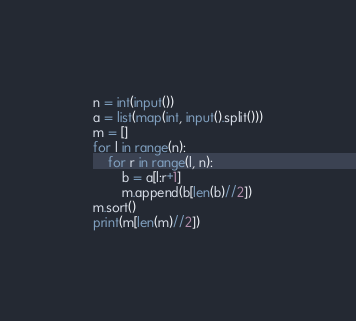<code> <loc_0><loc_0><loc_500><loc_500><_Python_>n = int(input())
a = list(map(int, input().split()))
m = []
for l in range(n):
    for r in range(l, n):
        b = a[l:r+1]
        m.append(b[len(b)//2])
m.sort()
print(m[len(m)//2])


</code> 